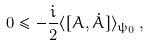Convert formula to latex. <formula><loc_0><loc_0><loc_500><loc_500>0 \leq - \frac { i } { 2 } \langle [ A , \dot { A } ] \rangle _ { \psi _ { 0 } } \, ,</formula> 